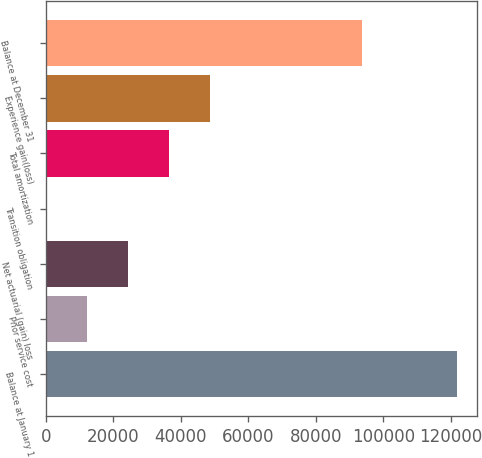<chart> <loc_0><loc_0><loc_500><loc_500><bar_chart><fcel>Balance at January 1<fcel>Prior service cost<fcel>Net actuarial (gain) loss<fcel>Transition obligation<fcel>Total amortization<fcel>Experience gain(loss)<fcel>Balance at December 31<nl><fcel>121704<fcel>12176.7<fcel>24346.4<fcel>7<fcel>36516.1<fcel>48685.8<fcel>93674<nl></chart> 